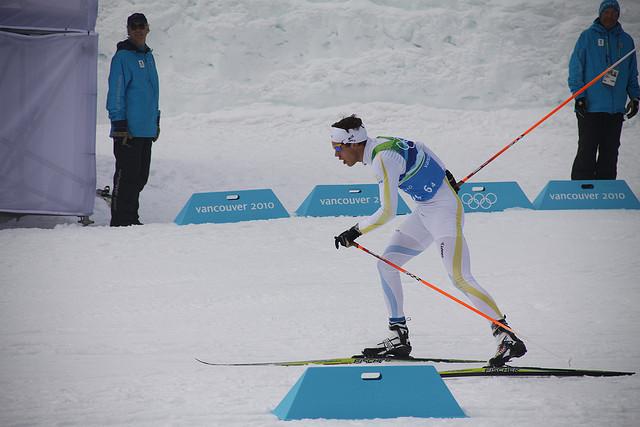Where is this?
Answer briefly. Vancouver. What sport is this man portraying?
Give a very brief answer. Skiing. What sport is being played?
Concise answer only. Skiing. What is the weather like?
Quick response, please. Cold. 